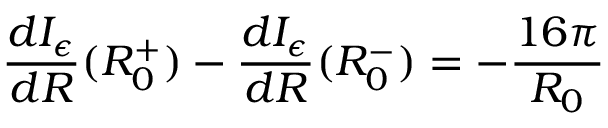<formula> <loc_0><loc_0><loc_500><loc_500>\frac { d I _ { \epsilon } } { d R } ( R _ { 0 } ^ { + } ) - \frac { d I _ { \epsilon } } { d R } ( R _ { 0 } ^ { - } ) = - \frac { 1 6 \pi } { R _ { 0 } }</formula> 